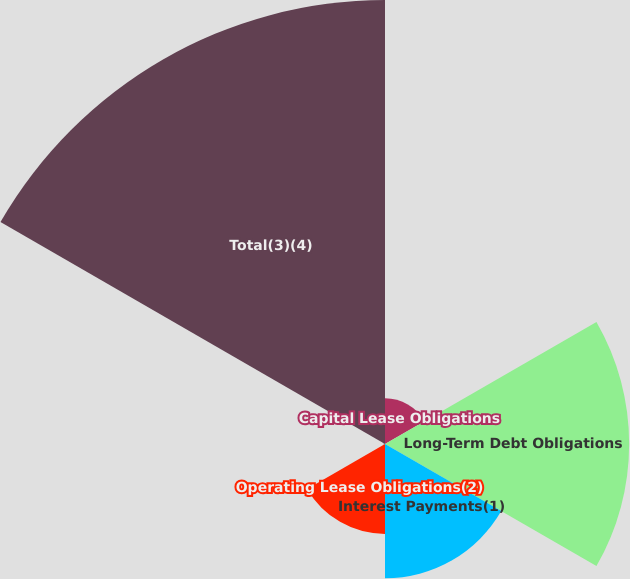<chart> <loc_0><loc_0><loc_500><loc_500><pie_chart><fcel>Capital Lease Obligations<fcel>Long-Term Debt Obligations<fcel>Interest Payments(1)<fcel>Operating Lease Obligations(2)<fcel>Purchase and Asset Retirement<fcel>Total(3)(4)<nl><fcel>4.76%<fcel>25.45%<fcel>13.99%<fcel>9.37%<fcel>0.15%<fcel>46.28%<nl></chart> 